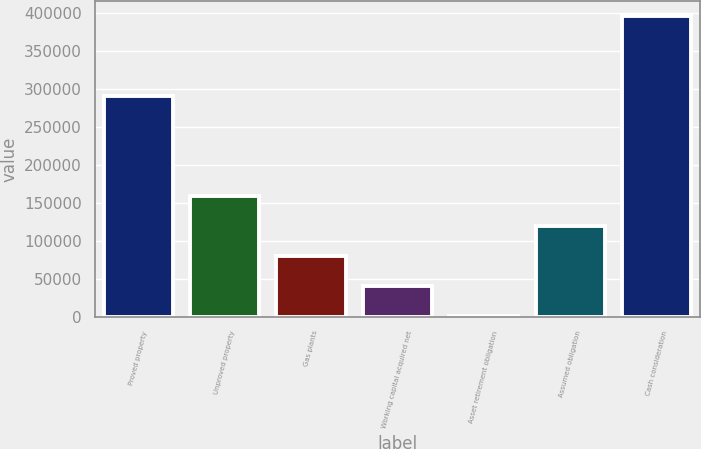<chart> <loc_0><loc_0><loc_500><loc_500><bar_chart><fcel>Proved property<fcel>Unproved property<fcel>Gas plants<fcel>Working capital acquired net<fcel>Asset retirement obligation<fcel>Assumed obligation<fcel>Cash consideration<nl><fcel>289916<fcel>159329<fcel>80420<fcel>40965.5<fcel>1511<fcel>119874<fcel>396056<nl></chart> 